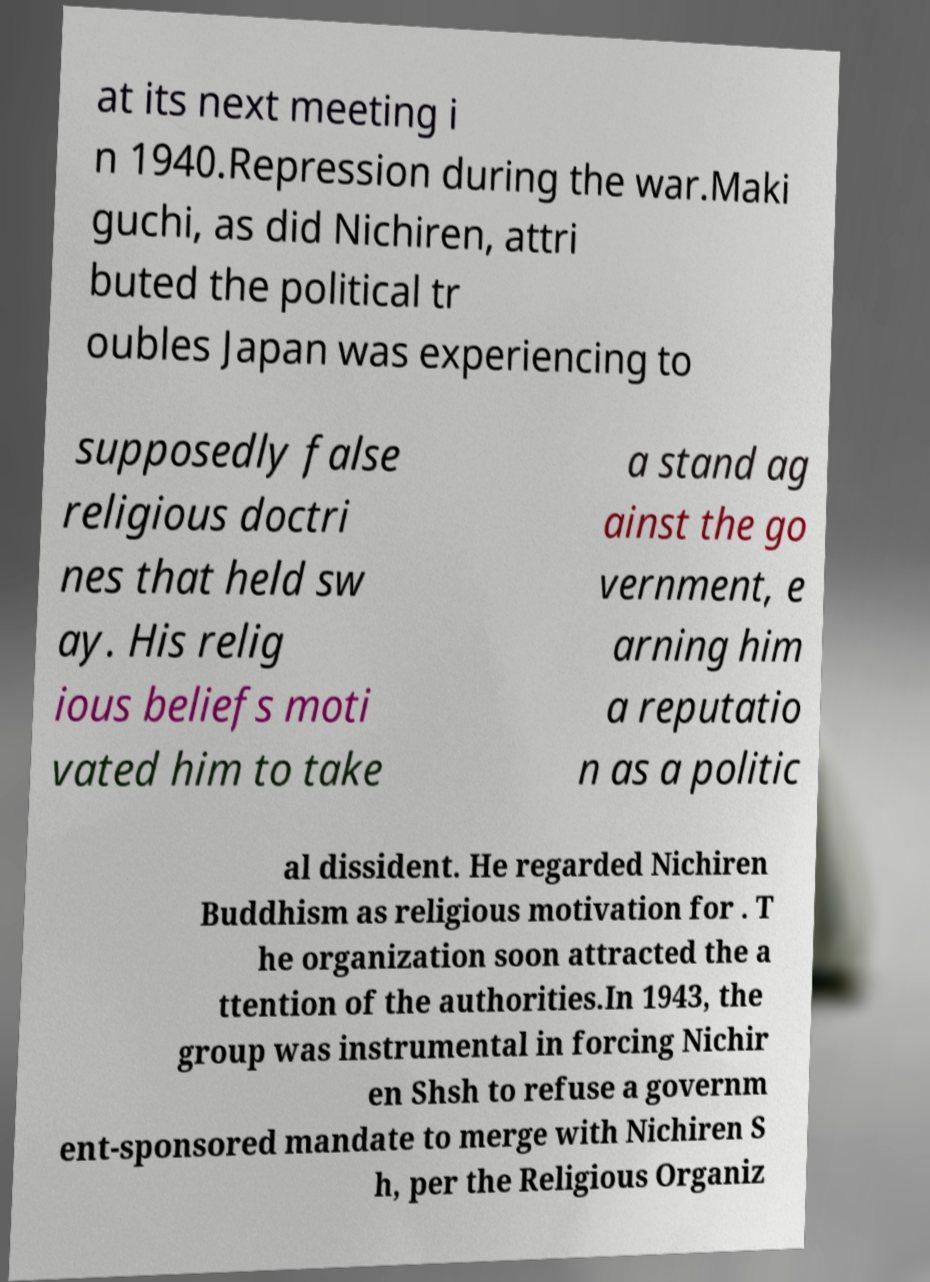I need the written content from this picture converted into text. Can you do that? at its next meeting i n 1940.Repression during the war.Maki guchi, as did Nichiren, attri buted the political tr oubles Japan was experiencing to supposedly false religious doctri nes that held sw ay. His relig ious beliefs moti vated him to take a stand ag ainst the go vernment, e arning him a reputatio n as a politic al dissident. He regarded Nichiren Buddhism as religious motivation for . T he organization soon attracted the a ttention of the authorities.In 1943, the group was instrumental in forcing Nichir en Shsh to refuse a governm ent-sponsored mandate to merge with Nichiren S h, per the Religious Organiz 